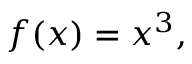<formula> <loc_0><loc_0><loc_500><loc_500>f ( x ) = x ^ { 3 } ,</formula> 